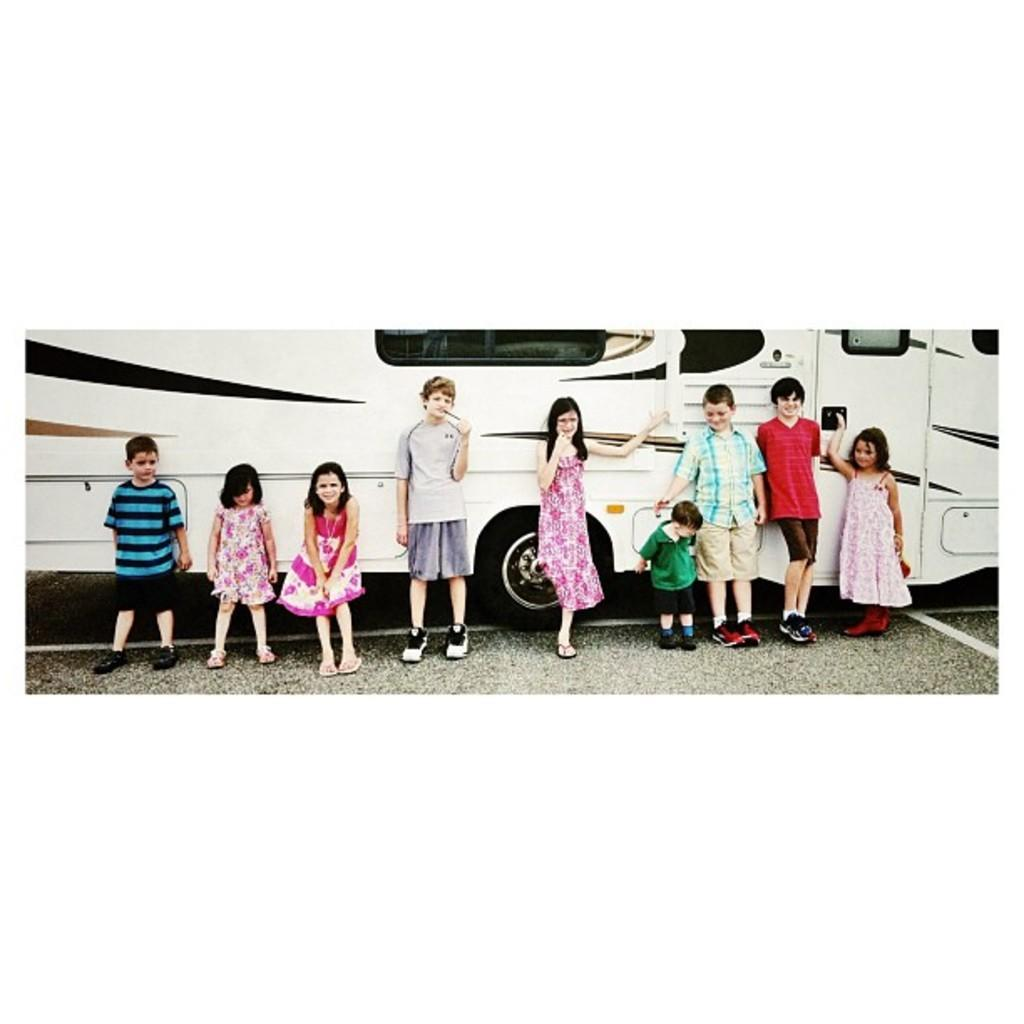What is the main subject of the image? The main subject of the image is a group of children. Where are the children located in the image? The children are standing on the road in the image. What else can be seen on the road in the image? There is a bus on the road in the image. What type of roof can be seen on the bus in the image? There is no roof visible in the image, as the focus is on the children and the bus is not shown in enough detail to see its roof. 